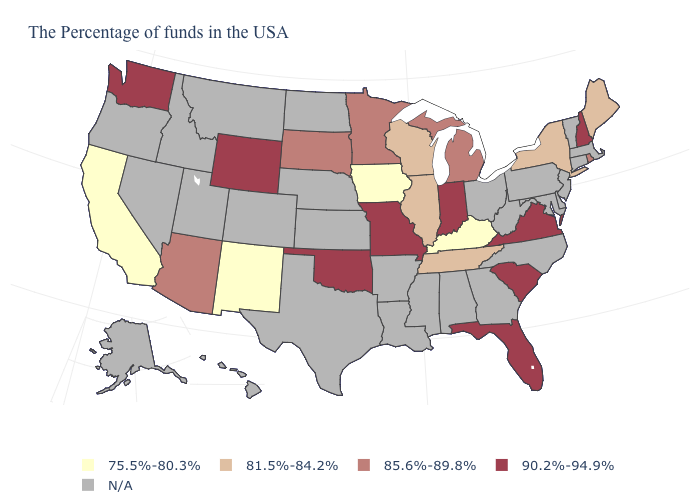How many symbols are there in the legend?
Concise answer only. 5. Is the legend a continuous bar?
Be succinct. No. What is the value of Connecticut?
Write a very short answer. N/A. What is the highest value in the West ?
Answer briefly. 90.2%-94.9%. What is the lowest value in the USA?
Give a very brief answer. 75.5%-80.3%. Which states hav the highest value in the South?
Answer briefly. Virginia, South Carolina, Florida, Oklahoma. Name the states that have a value in the range 81.5%-84.2%?
Answer briefly. Maine, New York, Tennessee, Wisconsin, Illinois. What is the highest value in the USA?
Quick response, please. 90.2%-94.9%. What is the value of Virginia?
Be succinct. 90.2%-94.9%. What is the value of North Carolina?
Answer briefly. N/A. What is the value of New Mexico?
Answer briefly. 75.5%-80.3%. Name the states that have a value in the range 75.5%-80.3%?
Keep it brief. Kentucky, Iowa, New Mexico, California. What is the lowest value in the South?
Answer briefly. 75.5%-80.3%. Name the states that have a value in the range 85.6%-89.8%?
Quick response, please. Rhode Island, Michigan, Minnesota, South Dakota, Arizona. 